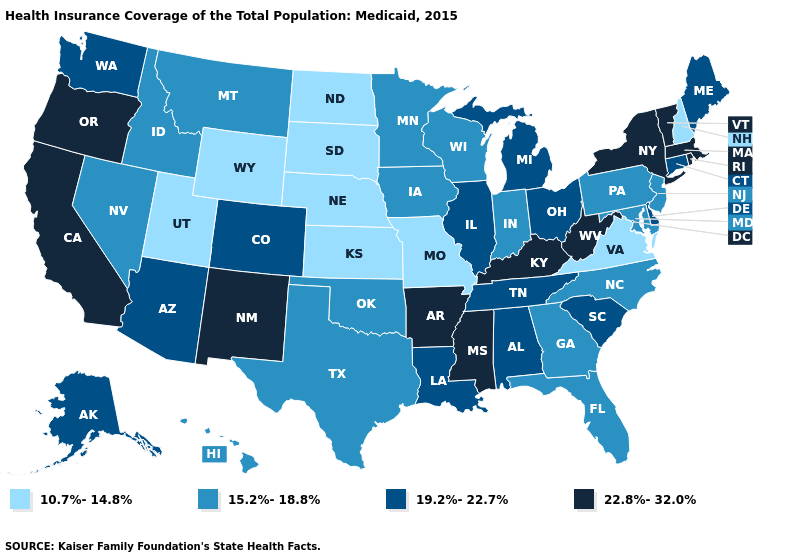What is the lowest value in the USA?
Short answer required. 10.7%-14.8%. Among the states that border Michigan , does Ohio have the highest value?
Give a very brief answer. Yes. Does the map have missing data?
Short answer required. No. What is the value of Oregon?
Write a very short answer. 22.8%-32.0%. What is the highest value in the USA?
Be succinct. 22.8%-32.0%. How many symbols are there in the legend?
Concise answer only. 4. Name the states that have a value in the range 15.2%-18.8%?
Quick response, please. Florida, Georgia, Hawaii, Idaho, Indiana, Iowa, Maryland, Minnesota, Montana, Nevada, New Jersey, North Carolina, Oklahoma, Pennsylvania, Texas, Wisconsin. Does the first symbol in the legend represent the smallest category?
Keep it brief. Yes. Does Michigan have the same value as Washington?
Write a very short answer. Yes. What is the lowest value in the USA?
Concise answer only. 10.7%-14.8%. What is the highest value in the USA?
Keep it brief. 22.8%-32.0%. How many symbols are there in the legend?
Quick response, please. 4. Name the states that have a value in the range 22.8%-32.0%?
Be succinct. Arkansas, California, Kentucky, Massachusetts, Mississippi, New Mexico, New York, Oregon, Rhode Island, Vermont, West Virginia. What is the highest value in the USA?
Short answer required. 22.8%-32.0%. Does Utah have the lowest value in the West?
Quick response, please. Yes. 